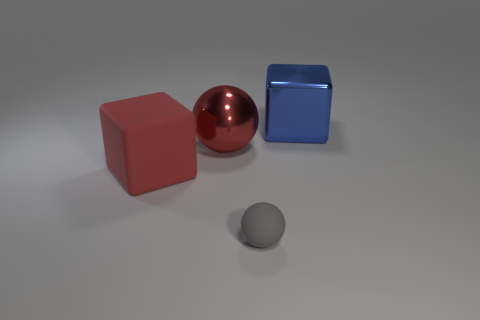Are there any large purple shiny objects?
Ensure brevity in your answer.  No. There is a cube right of the gray matte object; what material is it?
Offer a terse response. Metal. There is a large ball that is the same color as the big matte object; what is its material?
Provide a short and direct response. Metal. What number of small things are either red blocks or green metal cubes?
Make the answer very short. 0. The large matte object has what color?
Ensure brevity in your answer.  Red. There is a ball that is behind the small gray object; is there a blue metallic block behind it?
Offer a very short reply. Yes. Is the number of large things on the left side of the blue shiny block less than the number of matte objects?
Give a very brief answer. No. Are the small gray thing to the left of the blue shiny object and the red block made of the same material?
Ensure brevity in your answer.  Yes. What is the color of the big ball that is made of the same material as the blue cube?
Your answer should be compact. Red. Are there fewer blue metal objects on the left side of the big blue metal object than big cubes that are right of the tiny gray rubber sphere?
Provide a succinct answer. Yes. 